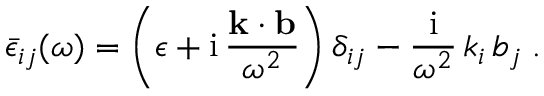Convert formula to latex. <formula><loc_0><loc_0><loc_500><loc_500>{ \bar { \epsilon } } _ { i j } ( \omega ) = \left ( \epsilon + i \, \frac { k \cdot b } { { \omega } ^ { 2 } } \right ) { \delta } _ { i j } - \frac { i } { { \omega } ^ { 2 } } \, k _ { i } \, b _ { j } \, .</formula> 